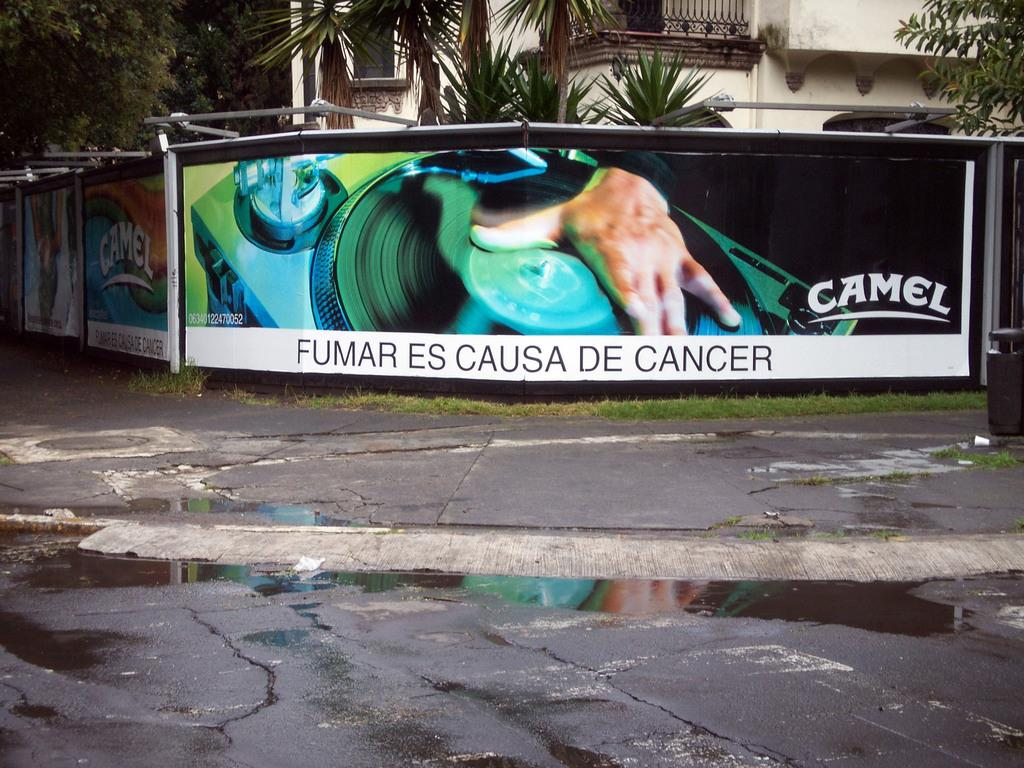What is covering the road in the image? There is water on the road in the image. What objects can be seen in the image besides the road? There are boards and a building visible in the image. What type of natural elements are present in the image? There are trees in the image. What degree does the son of the person who built the building have? There is no information about a person who built the building or their son's degree in the image. 